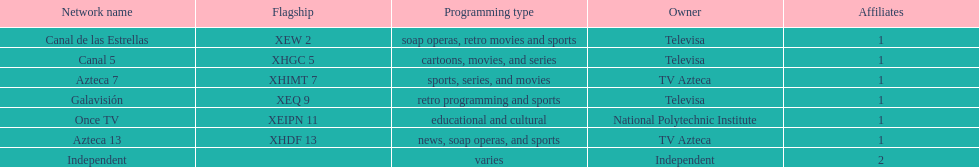How many networks do not air sports? 2. 